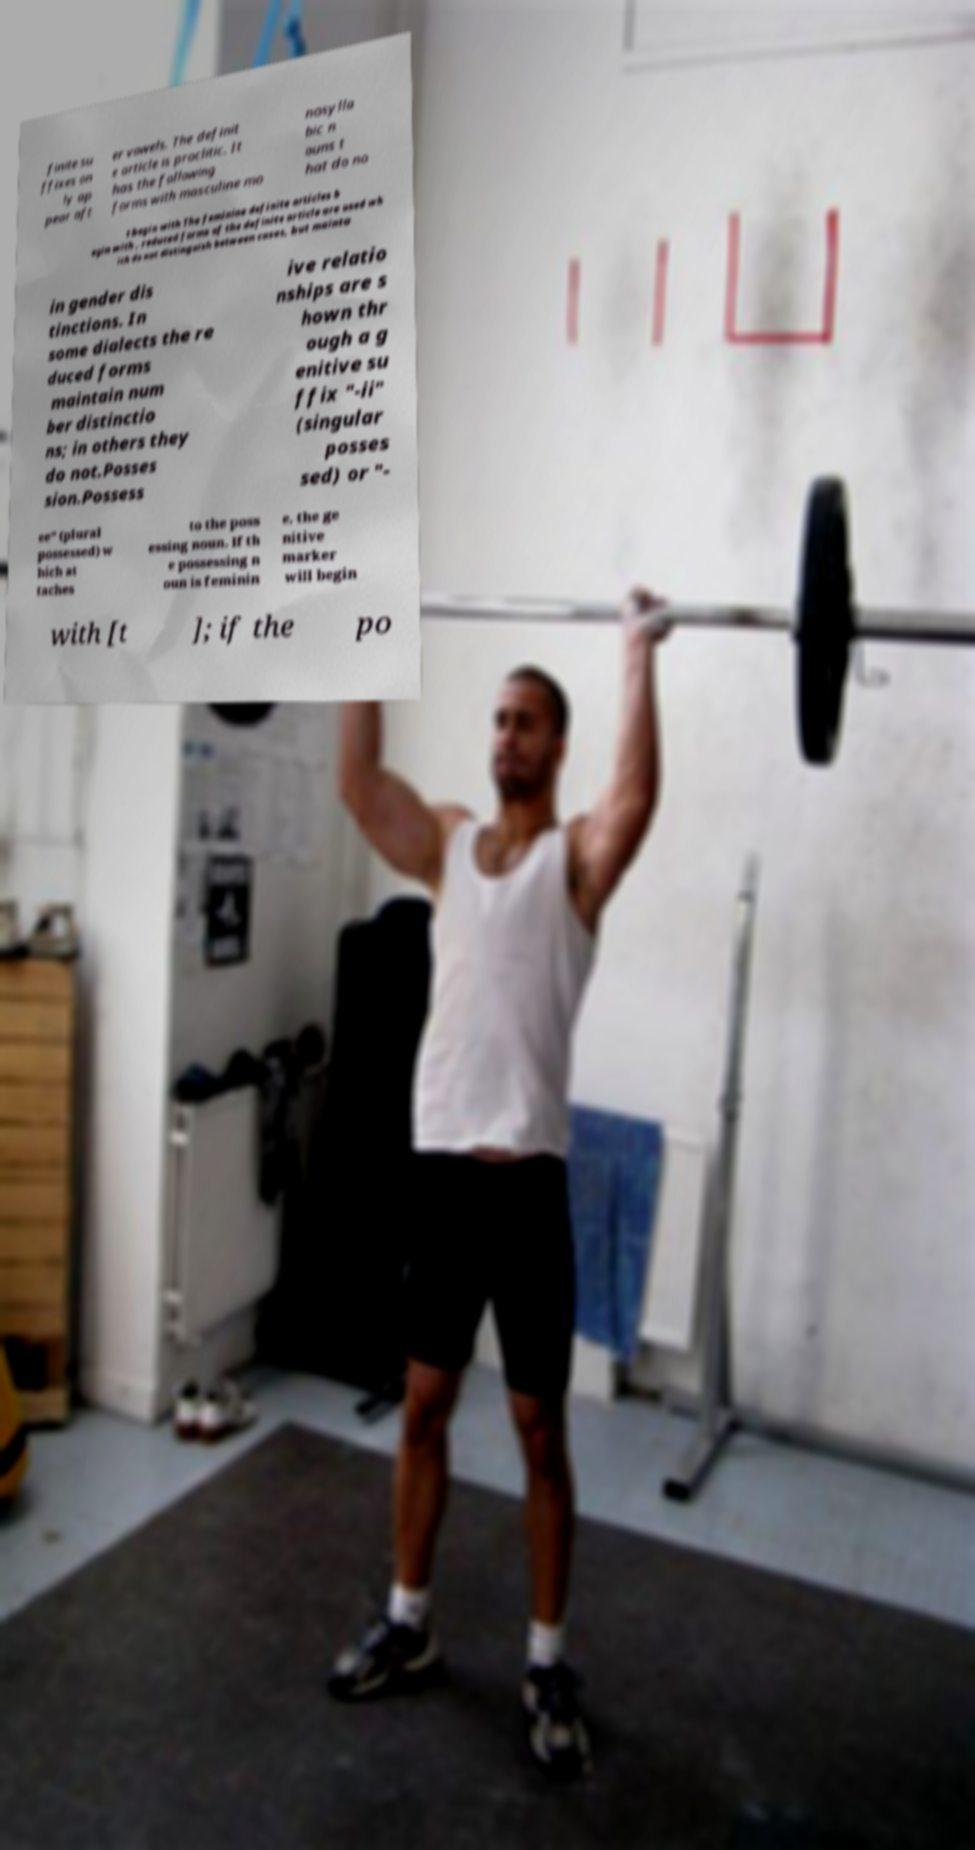There's text embedded in this image that I need extracted. Can you transcribe it verbatim? finite su ffixes on ly ap pear aft er vowels. The definit e article is proclitic. It has the following forms with masculine mo nosylla bic n ouns t hat do no t begin with The feminine definite articles b egin with , reduced forms of the definite article are used wh ich do not distinguish between cases, but mainta in gender dis tinctions. In some dialects the re duced forms maintain num ber distinctio ns; in others they do not.Posses sion.Possess ive relatio nships are s hown thr ough a g enitive su ffix "-ii" (singular posses sed) or "- ee" (plural possessed) w hich at taches to the poss essing noun. If th e possessing n oun is feminin e, the ge nitive marker will begin with [t ]; if the po 